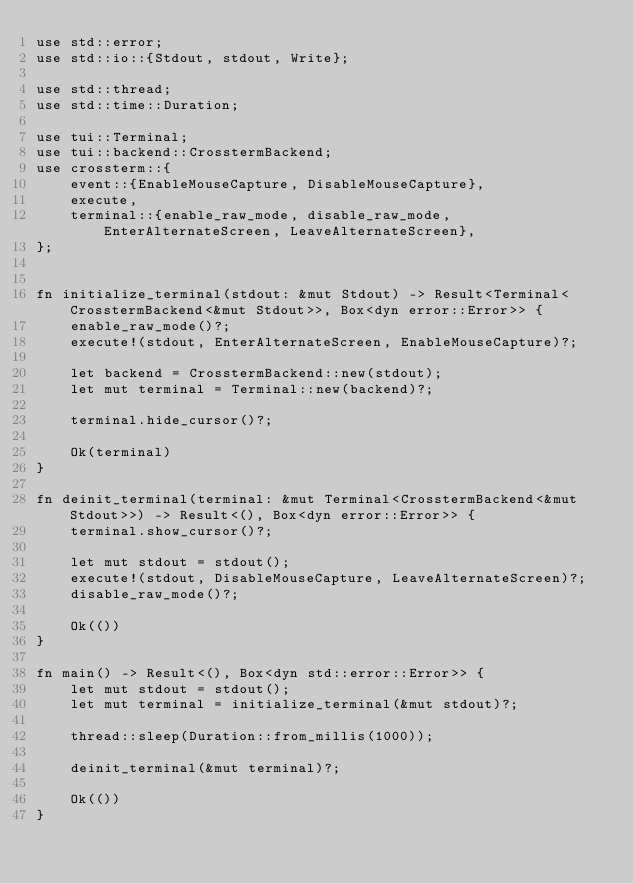<code> <loc_0><loc_0><loc_500><loc_500><_Rust_>use std::error;
use std::io::{Stdout, stdout, Write};

use std::thread;
use std::time::Duration;

use tui::Terminal;
use tui::backend::CrosstermBackend;
use crossterm::{
    event::{EnableMouseCapture, DisableMouseCapture},
    execute,
    terminal::{enable_raw_mode, disable_raw_mode, EnterAlternateScreen, LeaveAlternateScreen},
};


fn initialize_terminal(stdout: &mut Stdout) -> Result<Terminal<CrosstermBackend<&mut Stdout>>, Box<dyn error::Error>> {
    enable_raw_mode()?;
    execute!(stdout, EnterAlternateScreen, EnableMouseCapture)?;

    let backend = CrosstermBackend::new(stdout);
    let mut terminal = Terminal::new(backend)?;

    terminal.hide_cursor()?;

    Ok(terminal)
}

fn deinit_terminal(terminal: &mut Terminal<CrosstermBackend<&mut Stdout>>) -> Result<(), Box<dyn error::Error>> {
    terminal.show_cursor()?;

    let mut stdout = stdout();
    execute!(stdout, DisableMouseCapture, LeaveAlternateScreen)?;
    disable_raw_mode()?;

    Ok(())
}

fn main() -> Result<(), Box<dyn std::error::Error>> {
    let mut stdout = stdout();
    let mut terminal = initialize_terminal(&mut stdout)?;

    thread::sleep(Duration::from_millis(1000));

    deinit_terminal(&mut terminal)?;

    Ok(())
}
</code> 